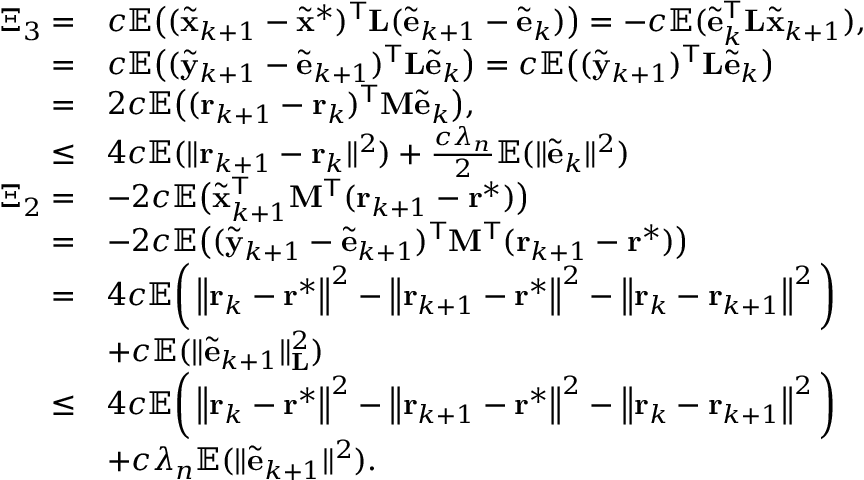Convert formula to latex. <formula><loc_0><loc_0><loc_500><loc_500>\begin{array} { r l } { \Xi _ { 3 } = } & { c \mathbb { E } \left ( ( \tilde { x } _ { k + 1 } - \tilde { x } ^ { \ast } ) ^ { T } L ( \tilde { e } _ { k + 1 } - \tilde { e } _ { k } ) \right ) = - c \mathbb { E } ( \tilde { e } _ { k } ^ { T } L \tilde { x } _ { k + 1 } ) , } \\ { = } & { c \mathbb { E } \left ( ( \tilde { y } _ { k + 1 } - \tilde { e } _ { k + 1 } ) ^ { T } L \tilde { e } _ { k } \right ) = c \mathbb { E } \left ( ( \tilde { y } _ { k + 1 } ) ^ { T } L \tilde { e } _ { k } \right ) } \\ { = } & { 2 c \mathbb { E } \left ( ( r _ { k + 1 } - r _ { k } ) ^ { T } M \tilde { e } _ { k } \right ) , } \\ { \leq } & { 4 c \mathbb { E } ( \| r _ { k + 1 } - r _ { k } \| ^ { 2 } ) + \frac { c \lambda _ { n } } { 2 } \mathbb { E } ( \| \tilde { e } _ { k } \| ^ { 2 } ) } \\ { \Xi _ { 2 } = } & { - 2 c \mathbb { E } \left ( \tilde { x } _ { k + 1 } ^ { T } M ^ { T } ( r _ { k + 1 } - r ^ { * } ) \right ) } \\ { = } & { - 2 c \mathbb { E } \left ( ( \tilde { y } _ { k + 1 } - \tilde { e } _ { k + 1 } ) ^ { T } M ^ { T } ( r _ { k + 1 } - r ^ { * } ) \right ) } \\ { = } & { 4 c \mathbb { E } \left ( \left \| r _ { k } - r ^ { * } \right \| ^ { 2 } - \left \| r _ { k + 1 } - r ^ { * } \right \| ^ { 2 } - \left \| r _ { k } - r _ { k + 1 } \right \| ^ { 2 } \right ) } & { + c \mathbb { E } ( \| \tilde { e } _ { k + 1 } \| _ { L } ^ { 2 } ) } \\ { \leq } & { 4 c \mathbb { E } \left ( \left \| r _ { k } - r ^ { * } \right \| ^ { 2 } - \left \| r _ { k + 1 } - r ^ { * } \right \| ^ { 2 } - \left \| r _ { k } - r _ { k + 1 } \right \| ^ { 2 } \right ) } \\ & { + c \lambda _ { n } \mathbb { E } ( \| \tilde { e } _ { k + 1 } \| ^ { 2 } ) . } \end{array}</formula> 